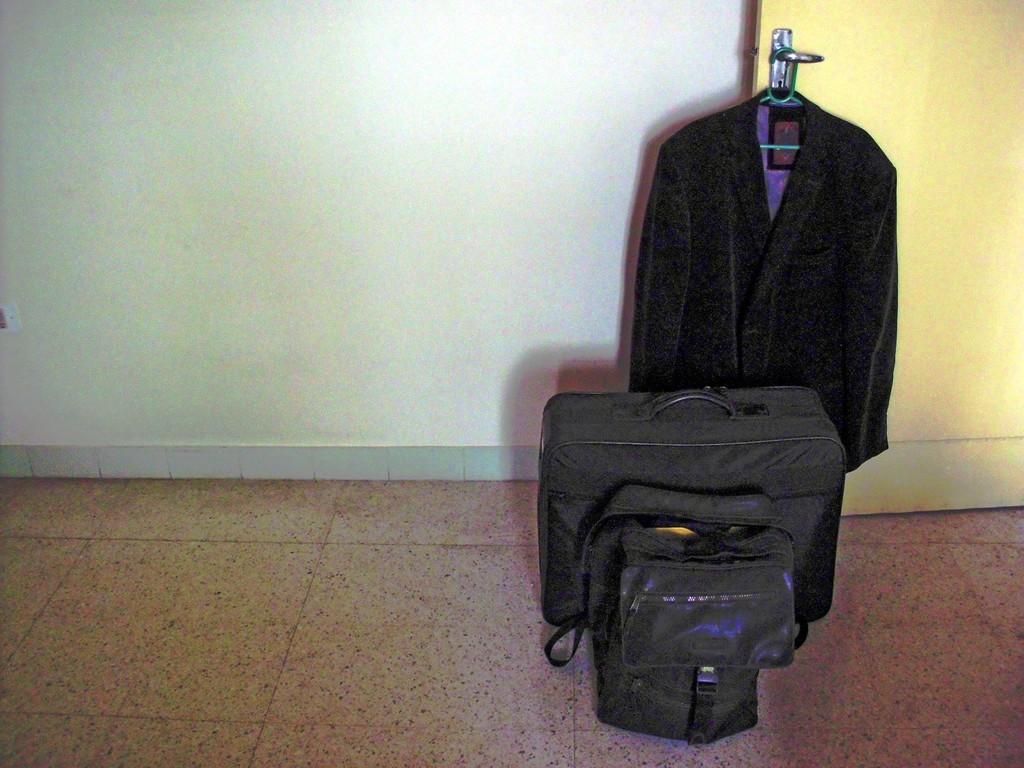Please provide a concise description of this image. In the foreground of the picture there are two bags. In the center of the picture there is a blazer. On the left there are tiles. On the top left there is wall. On the right there are tiles. On the top right there is a door. 